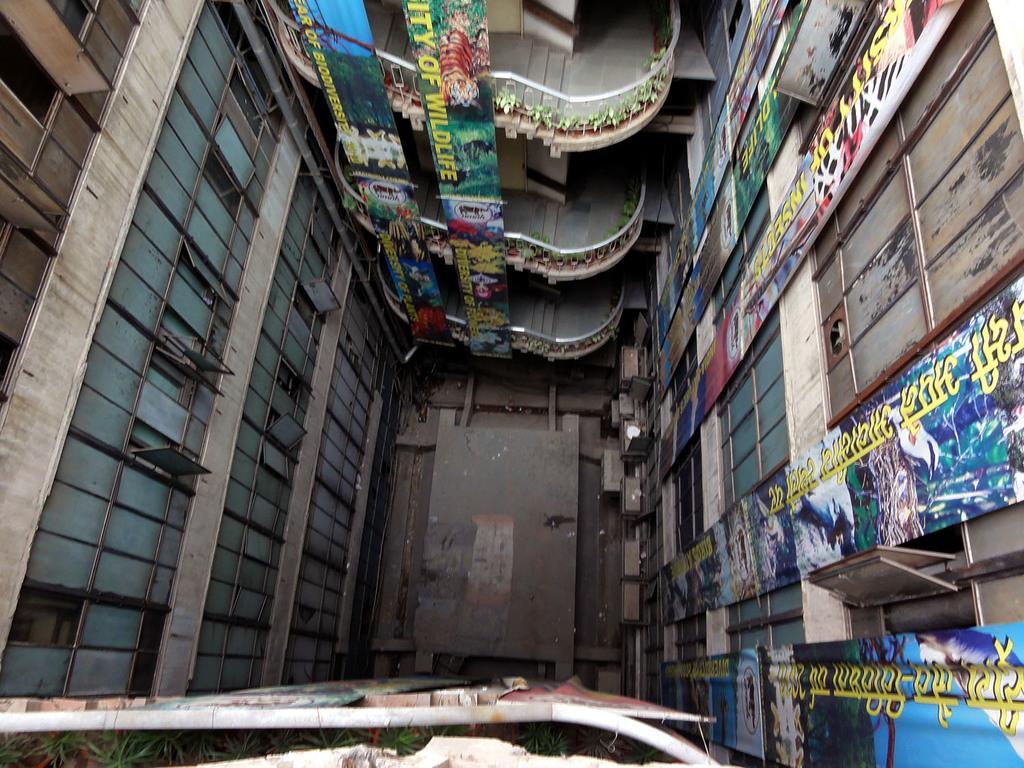Please provide a concise description of this image. In this picture we can see a building, where we can see banners, staircases, windows and some objects. 